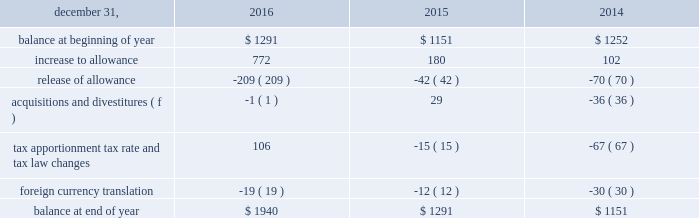In 2016 , arconic also recognized discrete income tax benefits related to the release of valuation allowances on certain net deferred tax assets in russia and canada of $ 19 and $ 20 respectively .
After weighing all available evidence , management determined that it was more likely than not that the net income tax benefits associated with the underlying deferred tax assets would be realizable based on historic cumulative income and projected taxable income .
Arconic also recorded additional valuation allowances in australia of $ 93 related to the separation transaction , in spain of $ 163 related to a tax law change and in luxembourg of $ 280 related to the separation transaction as well as a tax law change .
These valuation allowances fully offset current year changes in deferred tax asset balances of each respective jurisdiction , resulting in no net impact to tax expense .
The need for a valuation allowance will be reassessed on a continuous basis in future periods by each jurisdiction and , as a result , the allowances may increase or decrease based on changes in facts and circumstances .
In 2015 , arconic recognized an additional $ 141 discrete income tax charge for valuation allowances on certain deferred tax assets in iceland and suriname .
Of this amount , an $ 85 valuation allowance was established on the full value of the deferred tax assets in suriname , which were related mostly to employee benefits and tax loss carryforwards .
These deferred tax assets have an expiration period ranging from 2016 to 2022 ( as of december 31 , 2015 ) .
The remaining $ 56 charge relates to a valuation allowance established on a portion of the deferred tax assets recorded in iceland .
These deferred tax assets have an expiration period ranging from 2017 to 2023 .
After weighing all available positive and negative evidence , as described above , management determined that it was no longer more likely than not that arconic will realize the tax benefit of either of these deferred tax assets .
This was mainly driven by a decline in the outlook of the primary metals business , combined with prior year cumulative losses and a short expiration period .
In december 2011 , one of arconic 2019s former subsidiaries in brazil applied for a tax holiday related to its expanded mining and refining operations .
During 2013 , the application was amended and re-filed and , separately , a similar application was filed for another one of arconic 2019s former subsidiaries in brazil .
The deadline for the brazilian government to deny the application was july 11 , 2014 .
Since arconic did not receive notice that its applications were denied , the tax holiday took effect automatically on july 12 , 2014 .
As a result , the tax rate applicable to qualified holiday income for these subsidiaries decreased significantly ( from 34% ( 34 % ) to 15.25% ( 15.25 % ) ) , resulting in future cash tax savings over the 10-year holiday period ( retroactively effective as of january 1 , 2013 ) .
Additionally , a portion of one of the subsidiaries net deferred tax assets that reverses within the holiday period was remeasured at the new tax rate ( the net deferred tax asset of the other subsidiary was not remeasured since it could still be utilized against the subsidiary 2019s future earnings not subject to the tax holiday ) .
This remeasurement resulted in a decrease to that subsidiary 2019s net deferred tax assets and a noncash charge to earnings of $ 52 ( $ 31 after noncontrolling interests ) .
The table details the changes in the valuation allowance: .
The cumulative amount of arconic 2019s foreign undistributed net earnings for which no deferred taxes have been provided was approximately $ 450 at december 31 , 2016 .
Arconic has a number of commitments and obligations related to the company 2019s growth strategy in foreign jurisdictions .
As such , management has no plans to distribute such earnings in the foreseeable future , and , therefore , has determined it is not practicable to determine the related deferred tax liability. .
What was the increase in the balance at end of the year from 2015 to 2016? 
Rationale: it is the percentual increase observed in the balance at the end of the year , which is calculated by dividing the 2016's value by the 2015's then turned into a percentage .
Computations: ((1940 / 1291) - 1)
Answer: 0.50271. 